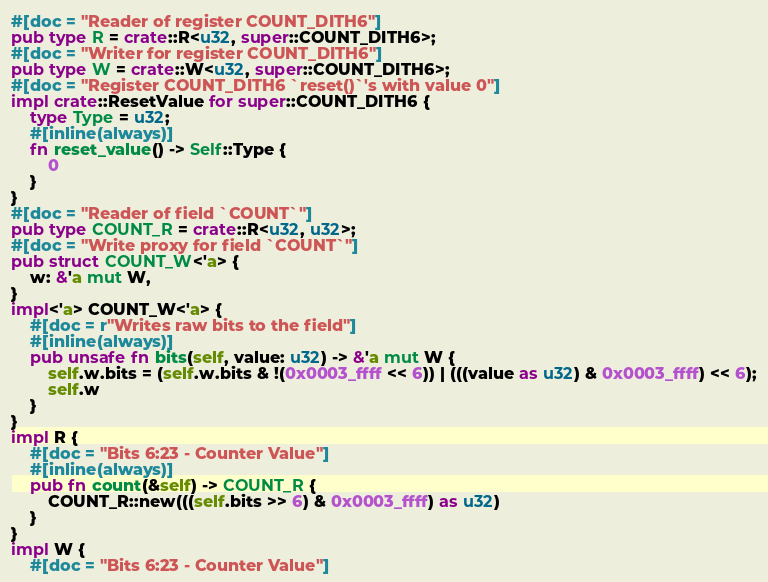<code> <loc_0><loc_0><loc_500><loc_500><_Rust_>#[doc = "Reader of register COUNT_DITH6"]
pub type R = crate::R<u32, super::COUNT_DITH6>;
#[doc = "Writer for register COUNT_DITH6"]
pub type W = crate::W<u32, super::COUNT_DITH6>;
#[doc = "Register COUNT_DITH6 `reset()`'s with value 0"]
impl crate::ResetValue for super::COUNT_DITH6 {
    type Type = u32;
    #[inline(always)]
    fn reset_value() -> Self::Type {
        0
    }
}
#[doc = "Reader of field `COUNT`"]
pub type COUNT_R = crate::R<u32, u32>;
#[doc = "Write proxy for field `COUNT`"]
pub struct COUNT_W<'a> {
    w: &'a mut W,
}
impl<'a> COUNT_W<'a> {
    #[doc = r"Writes raw bits to the field"]
    #[inline(always)]
    pub unsafe fn bits(self, value: u32) -> &'a mut W {
        self.w.bits = (self.w.bits & !(0x0003_ffff << 6)) | (((value as u32) & 0x0003_ffff) << 6);
        self.w
    }
}
impl R {
    #[doc = "Bits 6:23 - Counter Value"]
    #[inline(always)]
    pub fn count(&self) -> COUNT_R {
        COUNT_R::new(((self.bits >> 6) & 0x0003_ffff) as u32)
    }
}
impl W {
    #[doc = "Bits 6:23 - Counter Value"]</code> 